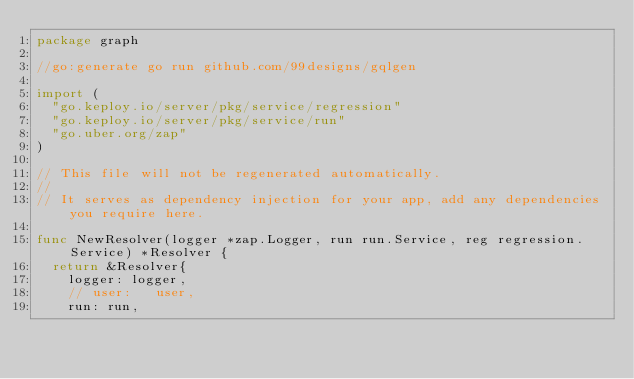Convert code to text. <code><loc_0><loc_0><loc_500><loc_500><_Go_>package graph

//go:generate go run github.com/99designs/gqlgen

import (
	"go.keploy.io/server/pkg/service/regression"
	"go.keploy.io/server/pkg/service/run"
	"go.uber.org/zap"
)

// This file will not be regenerated automatically.
//
// It serves as dependency injection for your app, add any dependencies you require here.

func NewResolver(logger *zap.Logger, run run.Service, reg regression.Service) *Resolver {
	return &Resolver{
		logger: logger,
		// user:   user,
		run: run,</code> 